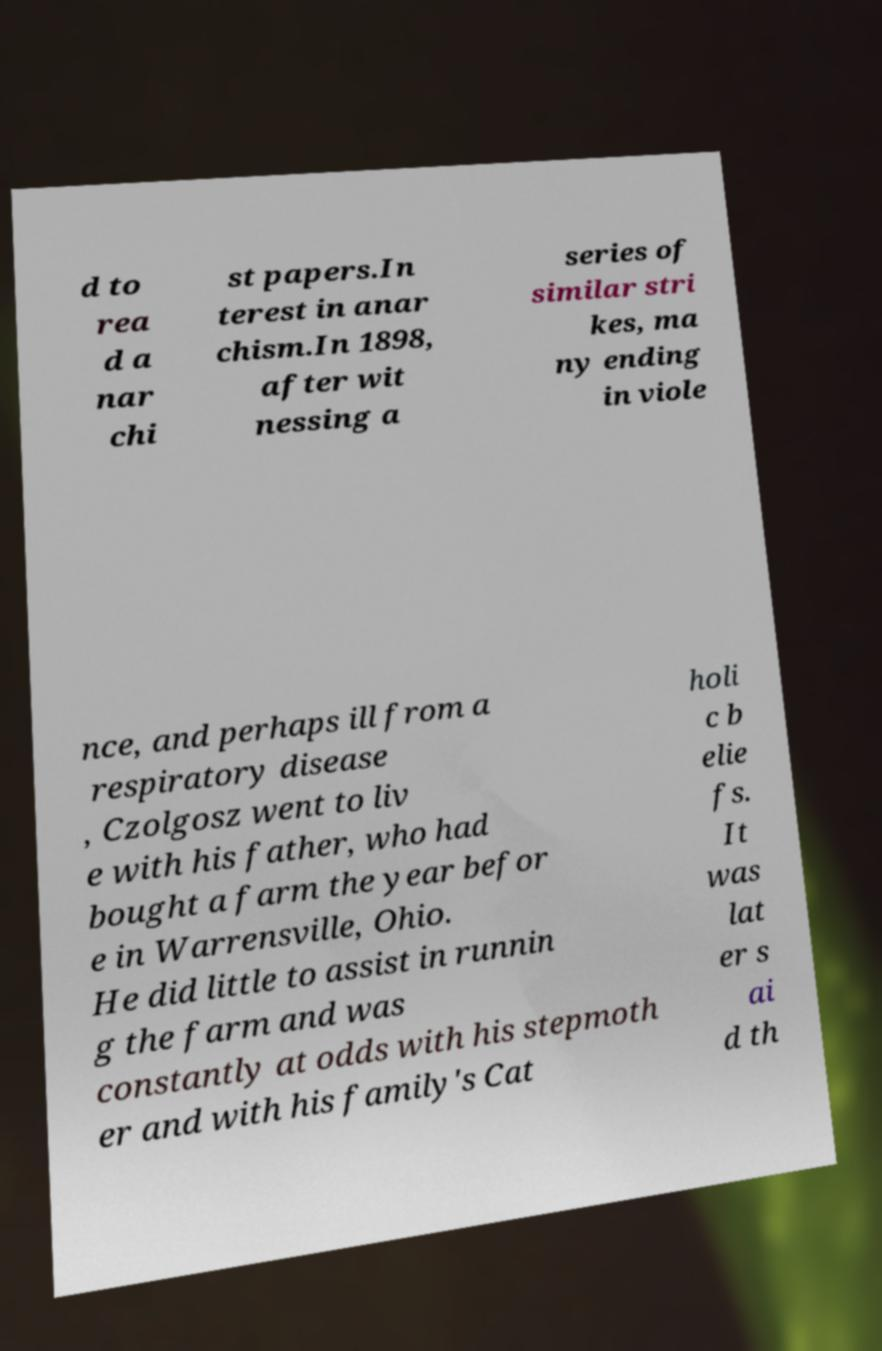Please read and relay the text visible in this image. What does it say? d to rea d a nar chi st papers.In terest in anar chism.In 1898, after wit nessing a series of similar stri kes, ma ny ending in viole nce, and perhaps ill from a respiratory disease , Czolgosz went to liv e with his father, who had bought a farm the year befor e in Warrensville, Ohio. He did little to assist in runnin g the farm and was constantly at odds with his stepmoth er and with his family's Cat holi c b elie fs. It was lat er s ai d th 